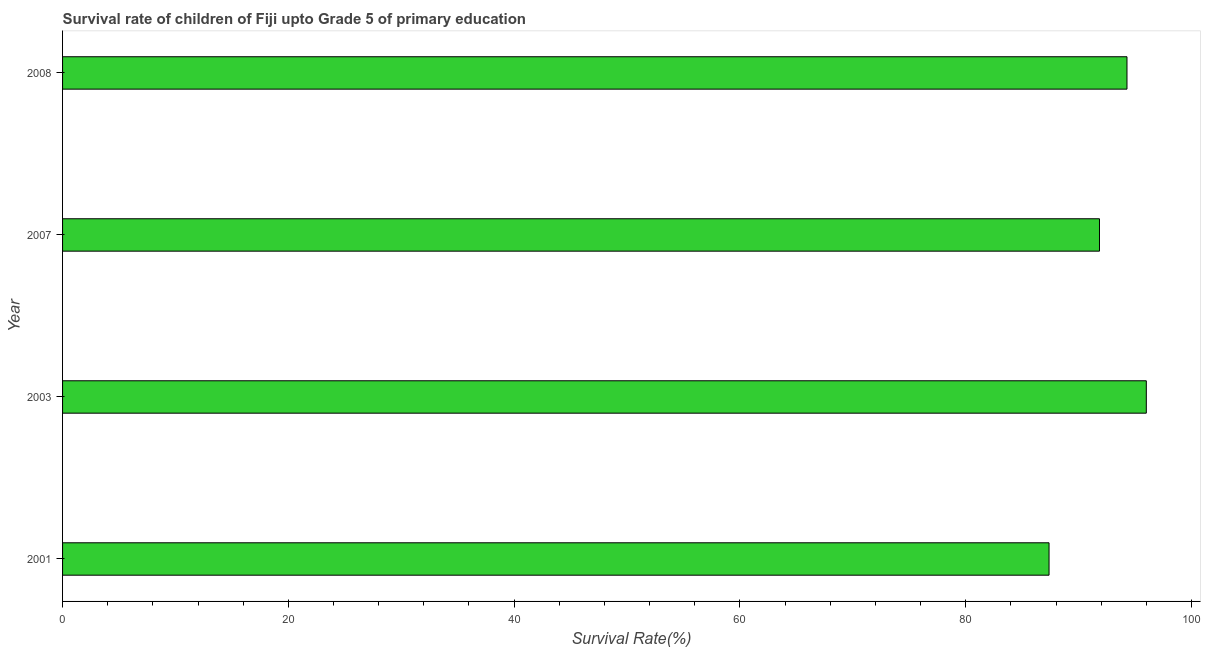Does the graph contain any zero values?
Your response must be concise. No. Does the graph contain grids?
Your answer should be very brief. No. What is the title of the graph?
Ensure brevity in your answer.  Survival rate of children of Fiji upto Grade 5 of primary education. What is the label or title of the X-axis?
Make the answer very short. Survival Rate(%). What is the label or title of the Y-axis?
Give a very brief answer. Year. What is the survival rate in 2007?
Give a very brief answer. 91.85. Across all years, what is the maximum survival rate?
Make the answer very short. 96. Across all years, what is the minimum survival rate?
Offer a very short reply. 87.38. In which year was the survival rate maximum?
Make the answer very short. 2003. What is the sum of the survival rate?
Provide a short and direct response. 369.52. What is the difference between the survival rate in 2003 and 2007?
Give a very brief answer. 4.15. What is the average survival rate per year?
Your answer should be compact. 92.38. What is the median survival rate?
Offer a terse response. 93.07. Is the difference between the survival rate in 2003 and 2008 greater than the difference between any two years?
Keep it short and to the point. No. What is the difference between the highest and the second highest survival rate?
Provide a short and direct response. 1.71. Is the sum of the survival rate in 2001 and 2007 greater than the maximum survival rate across all years?
Give a very brief answer. Yes. What is the difference between the highest and the lowest survival rate?
Provide a short and direct response. 8.62. In how many years, is the survival rate greater than the average survival rate taken over all years?
Your answer should be compact. 2. How many bars are there?
Ensure brevity in your answer.  4. Are all the bars in the graph horizontal?
Your response must be concise. Yes. How many years are there in the graph?
Offer a very short reply. 4. What is the Survival Rate(%) in 2001?
Offer a very short reply. 87.38. What is the Survival Rate(%) of 2003?
Your answer should be very brief. 96. What is the Survival Rate(%) in 2007?
Offer a terse response. 91.85. What is the Survival Rate(%) in 2008?
Give a very brief answer. 94.29. What is the difference between the Survival Rate(%) in 2001 and 2003?
Make the answer very short. -8.62. What is the difference between the Survival Rate(%) in 2001 and 2007?
Ensure brevity in your answer.  -4.47. What is the difference between the Survival Rate(%) in 2001 and 2008?
Your answer should be compact. -6.9. What is the difference between the Survival Rate(%) in 2003 and 2007?
Offer a very short reply. 4.15. What is the difference between the Survival Rate(%) in 2003 and 2008?
Offer a terse response. 1.71. What is the difference between the Survival Rate(%) in 2007 and 2008?
Give a very brief answer. -2.44. What is the ratio of the Survival Rate(%) in 2001 to that in 2003?
Offer a very short reply. 0.91. What is the ratio of the Survival Rate(%) in 2001 to that in 2007?
Ensure brevity in your answer.  0.95. What is the ratio of the Survival Rate(%) in 2001 to that in 2008?
Your answer should be compact. 0.93. What is the ratio of the Survival Rate(%) in 2003 to that in 2007?
Provide a succinct answer. 1.04. 